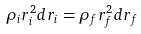Convert formula to latex. <formula><loc_0><loc_0><loc_500><loc_500>\rho _ { i } r _ { i } ^ { 2 } d r _ { i } = \rho _ { f } r _ { f } ^ { 2 } d r _ { f }</formula> 